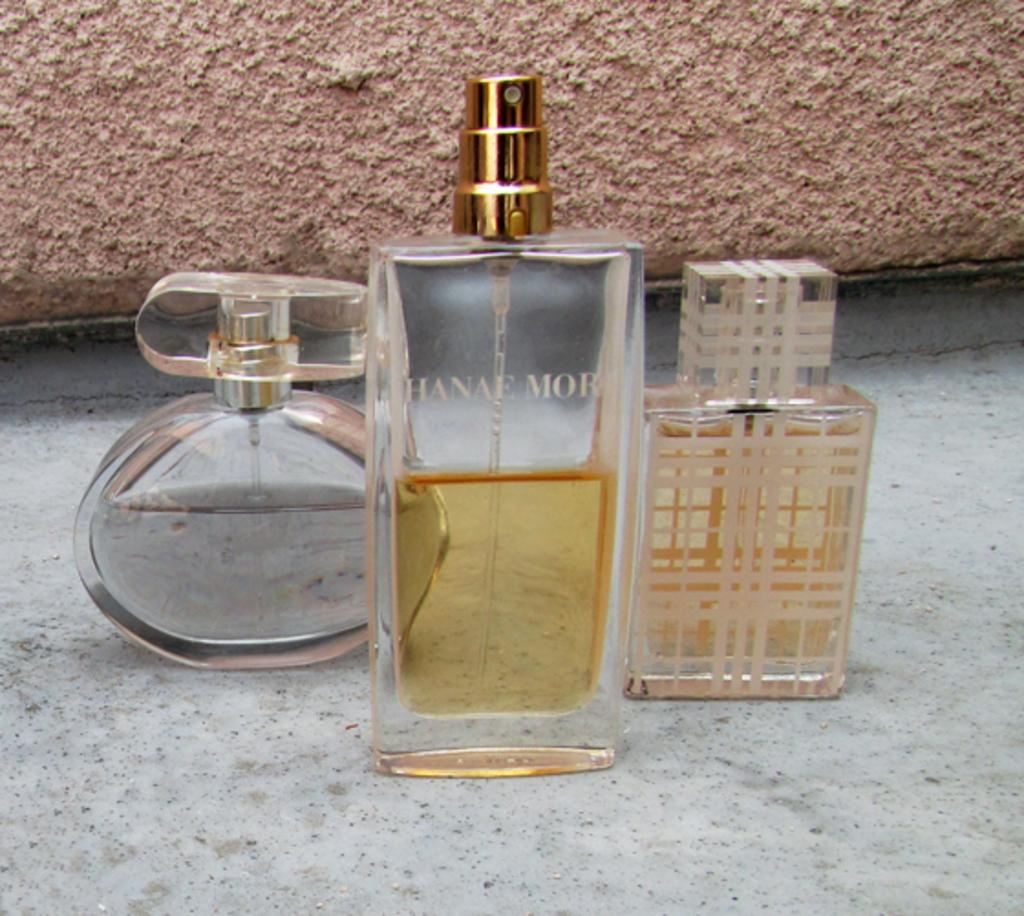<image>
Present a compact description of the photo's key features. The bottles of perfume, the middle of which says Hanae Mor. 